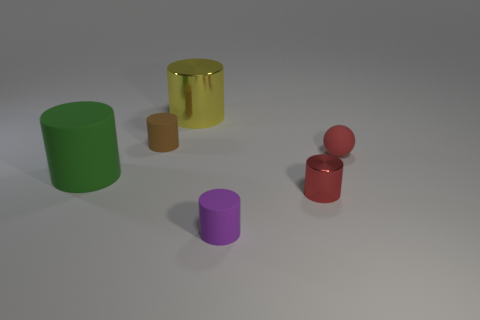There is a cylinder right of the small rubber cylinder right of the large metallic cylinder; what is it made of? The cylindrical object situated to the right of the small rubber cylinder, which in turn is right of the large metallic cylinder, appears to be made of a translucent material, likely glass or a clear plastic, given its see-through appearance and reflective surface. 